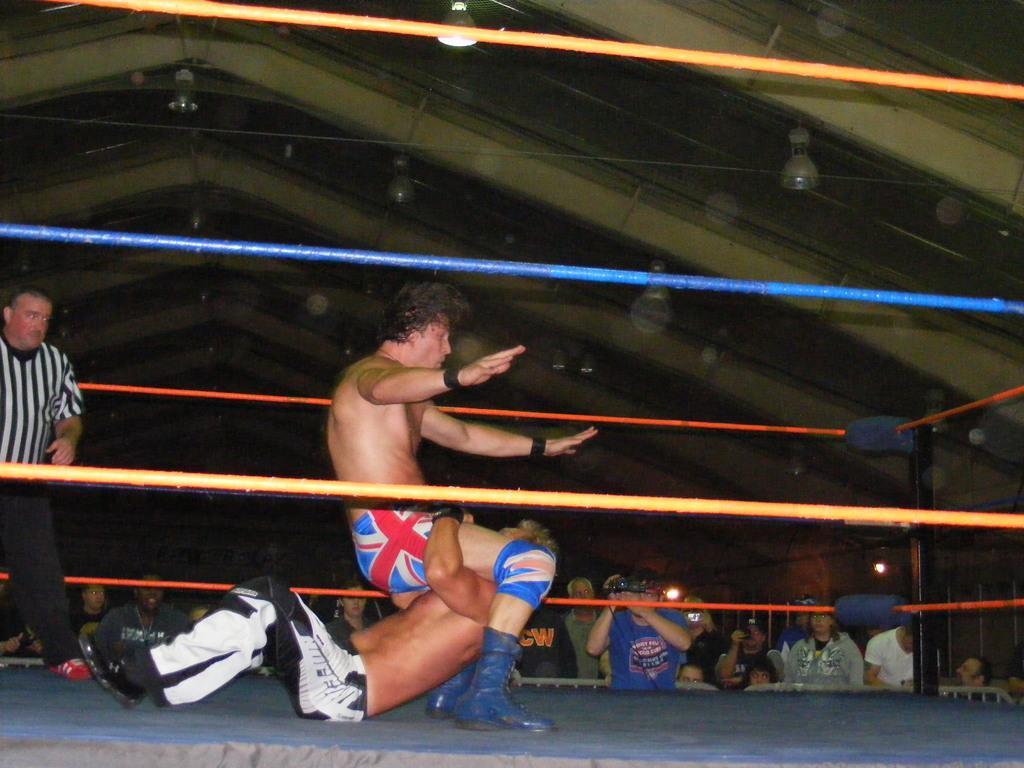How would you summarize this image in a sentence or two? In this image in the center there are two people who are fighting and there in a boxing ring, and on the left side there is one person standing. In the background there are a group of people standing, and some of them are holding cameras and at the top there are some lights, wires and ceiling and it seems that there is fence. 